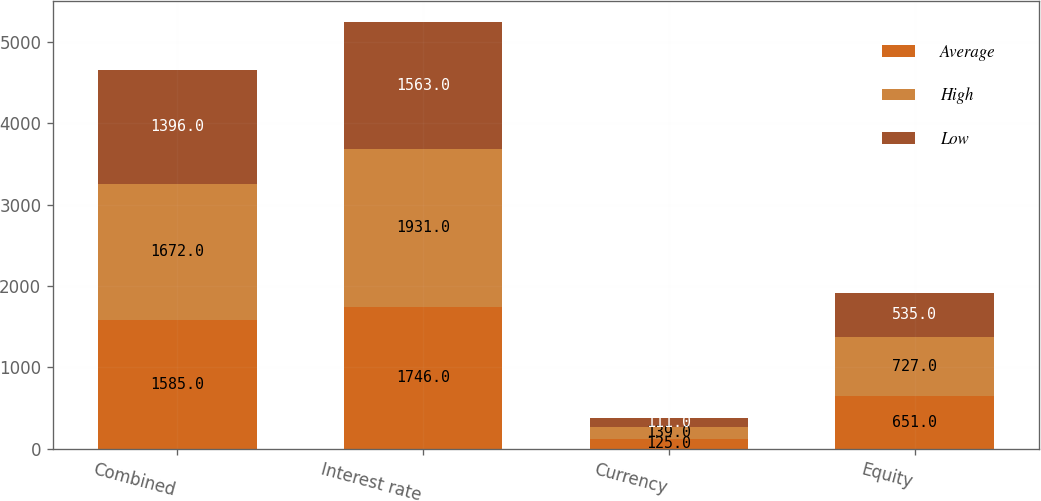Convert chart to OTSL. <chart><loc_0><loc_0><loc_500><loc_500><stacked_bar_chart><ecel><fcel>Combined<fcel>Interest rate<fcel>Currency<fcel>Equity<nl><fcel>Average<fcel>1585<fcel>1746<fcel>125<fcel>651<nl><fcel>High<fcel>1672<fcel>1931<fcel>139<fcel>727<nl><fcel>Low<fcel>1396<fcel>1563<fcel>111<fcel>535<nl></chart> 